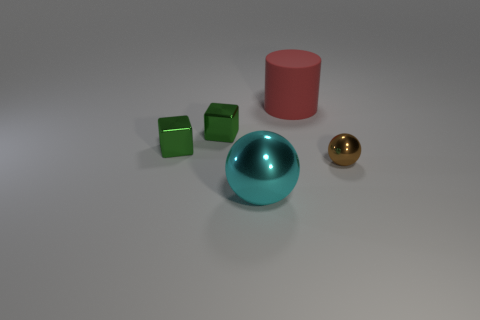If the objects were part of a set, what sort of game or activity could they be used for? These shapes could be part of an educational toy set designed to teach children about geometry and spatial relationships. The variety in shape and color can aid in differentiating and grouping the objects, facilitating activities like sorting or building. 